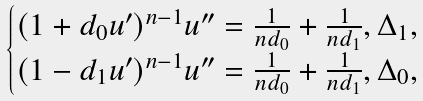Convert formula to latex. <formula><loc_0><loc_0><loc_500><loc_500>\begin{cases} ( 1 + d _ { 0 } u ^ { \prime } ) ^ { n - 1 } u ^ { \prime \prime } = \frac { 1 } { n d _ { 0 } } + \frac { 1 } { n d _ { 1 } } , \Delta _ { 1 } , \\ ( 1 - d _ { 1 } u ^ { \prime } ) ^ { n - 1 } u ^ { \prime \prime } = \frac { 1 } { n d _ { 0 } } + \frac { 1 } { n d _ { 1 } } , \Delta _ { 0 } , \end{cases}</formula> 